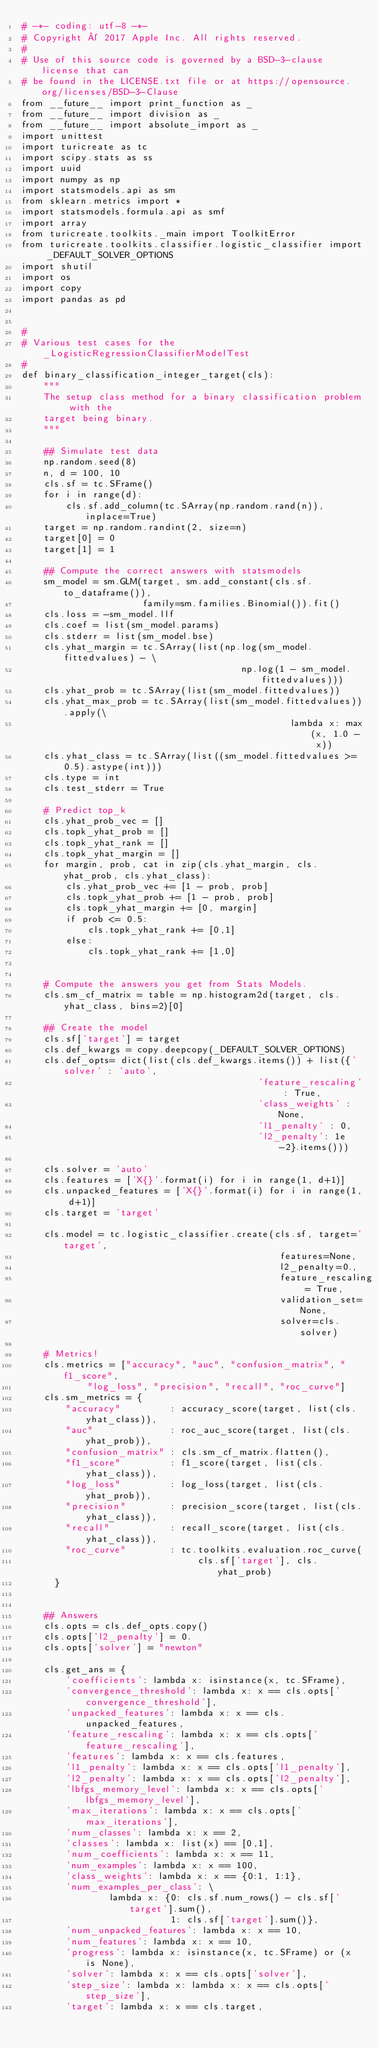Convert code to text. <code><loc_0><loc_0><loc_500><loc_500><_Python_># -*- coding: utf-8 -*-
# Copyright © 2017 Apple Inc. All rights reserved.
#
# Use of this source code is governed by a BSD-3-clause license that can
# be found in the LICENSE.txt file or at https://opensource.org/licenses/BSD-3-Clause
from __future__ import print_function as _
from __future__ import division as _
from __future__ import absolute_import as _
import unittest
import turicreate as tc
import scipy.stats as ss
import uuid
import numpy as np
import statsmodels.api as sm
from sklearn.metrics import *
import statsmodels.formula.api as smf
import array
from turicreate.toolkits._main import ToolkitError
from turicreate.toolkits.classifier.logistic_classifier import _DEFAULT_SOLVER_OPTIONS
import shutil
import os
import copy
import pandas as pd


#
# Various test cases for the _LogisticRegressionClassifierModelTest
#
def binary_classification_integer_target(cls):
    """
    The setup class method for a binary classification problem with the
    target being binary.
    """

    ## Simulate test data
    np.random.seed(8)
    n, d = 100, 10
    cls.sf = tc.SFrame()
    for i in range(d):
        cls.sf.add_column(tc.SArray(np.random.rand(n)), inplace=True)
    target = np.random.randint(2, size=n)
    target[0] = 0
    target[1] = 1

    ## Compute the correct answers with statsmodels
    sm_model = sm.GLM(target, sm.add_constant(cls.sf.to_dataframe()),
                      family=sm.families.Binomial()).fit()
    cls.loss = -sm_model.llf
    cls.coef = list(sm_model.params)
    cls.stderr = list(sm_model.bse)
    cls.yhat_margin = tc.SArray(list(np.log(sm_model.fittedvalues) - \
                                        np.log(1 - sm_model.fittedvalues)))
    cls.yhat_prob = tc.SArray(list(sm_model.fittedvalues))
    cls.yhat_max_prob = tc.SArray(list(sm_model.fittedvalues)).apply(\
                                                 lambda x: max(x, 1.0 - x))
    cls.yhat_class = tc.SArray(list((sm_model.fittedvalues >= 0.5).astype(int)))
    cls.type = int
    cls.test_stderr = True

    # Predict top_k
    cls.yhat_prob_vec = []
    cls.topk_yhat_prob = []
    cls.topk_yhat_rank = []
    cls.topk_yhat_margin = []
    for margin, prob, cat in zip(cls.yhat_margin, cls.yhat_prob, cls.yhat_class):
        cls.yhat_prob_vec += [1 - prob, prob]
        cls.topk_yhat_prob += [1 - prob, prob]
        cls.topk_yhat_margin += [0, margin]
        if prob <= 0.5:
            cls.topk_yhat_rank += [0,1]
        else:
            cls.topk_yhat_rank += [1,0]


    # Compute the answers you get from Stats Models.
    cls.sm_cf_matrix = table = np.histogram2d(target, cls.yhat_class, bins=2)[0]

    ## Create the model
    cls.sf['target'] = target
    cls.def_kwargs = copy.deepcopy(_DEFAULT_SOLVER_OPTIONS)
    cls.def_opts= dict(list(cls.def_kwargs.items()) + list({'solver' : 'auto',
                                           'feature_rescaling' : True,
                                           'class_weights' : None,
                                           'l1_penalty' : 0,
                                           'l2_penalty': 1e-2}.items()))

    cls.solver = 'auto'
    cls.features = ['X{}'.format(i) for i in range(1, d+1)]
    cls.unpacked_features = ['X{}'.format(i) for i in range(1, d+1)]
    cls.target = 'target'

    cls.model = tc.logistic_classifier.create(cls.sf, target='target',
                                               features=None,
                                               l2_penalty=0.,
                                               feature_rescaling = True,
                                               validation_set=None,
                                               solver=cls.solver)

    # Metrics!
    cls.metrics = ["accuracy", "auc", "confusion_matrix", "f1_score",
            "log_loss", "precision", "recall", "roc_curve"]
    cls.sm_metrics = {
        "accuracy"         : accuracy_score(target, list(cls.yhat_class)),
        "auc"              : roc_auc_score(target, list(cls.yhat_prob)),
        "confusion_matrix" : cls.sm_cf_matrix.flatten(),
        "f1_score"         : f1_score(target, list(cls.yhat_class)),
        "log_loss"         : log_loss(target, list(cls.yhat_prob)),
        "precision"        : precision_score(target, list(cls.yhat_class)),
        "recall"           : recall_score(target, list(cls.yhat_class)),
        "roc_curve"        : tc.toolkits.evaluation.roc_curve(
                                cls.sf['target'], cls.yhat_prob)
      }


    ## Answers
    cls.opts = cls.def_opts.copy()
    cls.opts['l2_penalty'] = 0.
    cls.opts['solver'] = "newton"

    cls.get_ans = {
        'coefficients': lambda x: isinstance(x, tc.SFrame),
        'convergence_threshold': lambda x: x == cls.opts['convergence_threshold'],
        'unpacked_features': lambda x: x == cls.unpacked_features,
        'feature_rescaling': lambda x: x == cls.opts['feature_rescaling'],
        'features': lambda x: x == cls.features,
        'l1_penalty': lambda x: x == cls.opts['l1_penalty'],
        'l2_penalty': lambda x: x == cls.opts['l2_penalty'],
        'lbfgs_memory_level': lambda x: x == cls.opts['lbfgs_memory_level'],
        'max_iterations': lambda x: x == cls.opts['max_iterations'],
        'num_classes': lambda x: x == 2,
        'classes': lambda x: list(x) == [0,1],
        'num_coefficients': lambda x: x == 11,
        'num_examples': lambda x: x == 100,
        'class_weights': lambda x: x == {0:1, 1:1},
        'num_examples_per_class': \
                lambda x: {0: cls.sf.num_rows() - cls.sf['target'].sum(),
                           1: cls.sf['target'].sum()},
        'num_unpacked_features': lambda x: x == 10,
        'num_features': lambda x: x == 10,
        'progress': lambda x: isinstance(x, tc.SFrame) or (x is None),
        'solver': lambda x: x == cls.opts['solver'],
        'step_size': lambda x: lambda x: x == cls.opts['step_size'],
        'target': lambda x: x == cls.target,</code> 